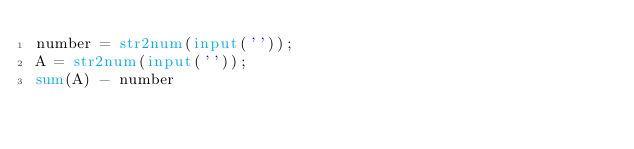<code> <loc_0><loc_0><loc_500><loc_500><_Octave_>number = str2num(input(''));
A = str2num(input(''));
sum(A) - number</code> 